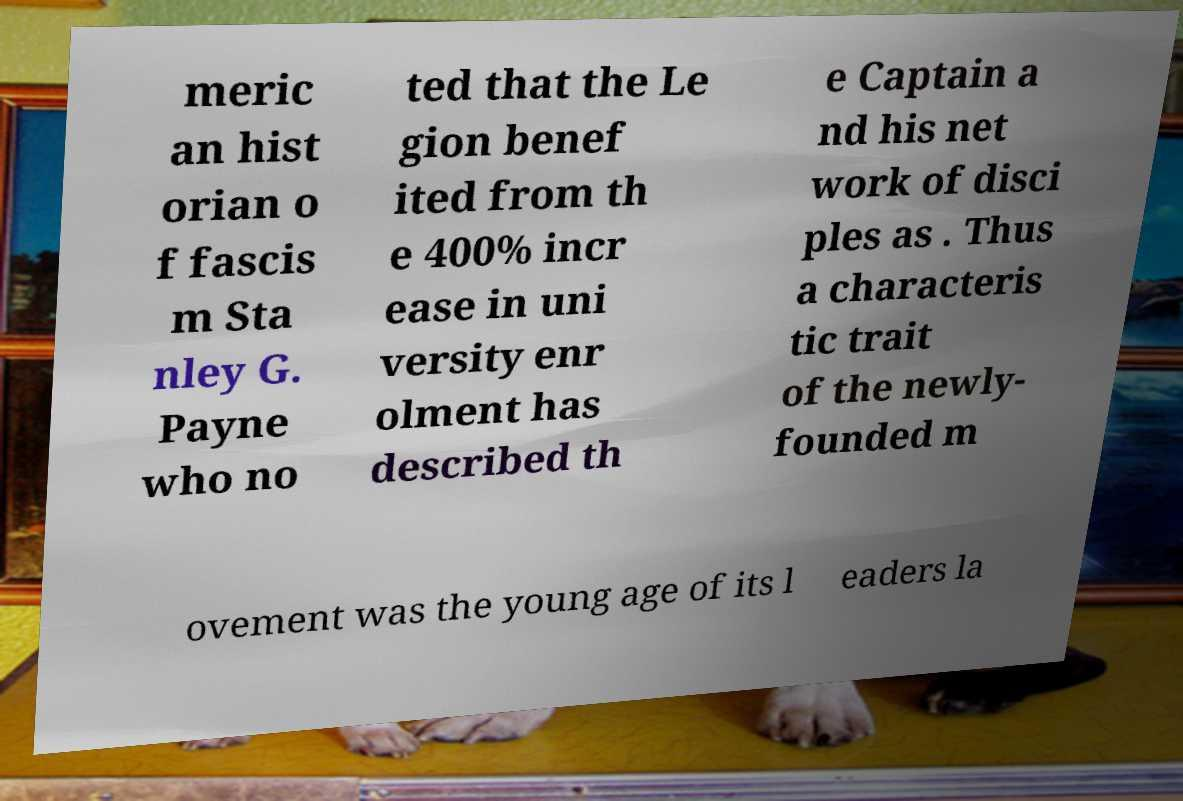Please read and relay the text visible in this image. What does it say? meric an hist orian o f fascis m Sta nley G. Payne who no ted that the Le gion benef ited from th e 400% incr ease in uni versity enr olment has described th e Captain a nd his net work of disci ples as . Thus a characteris tic trait of the newly- founded m ovement was the young age of its l eaders la 